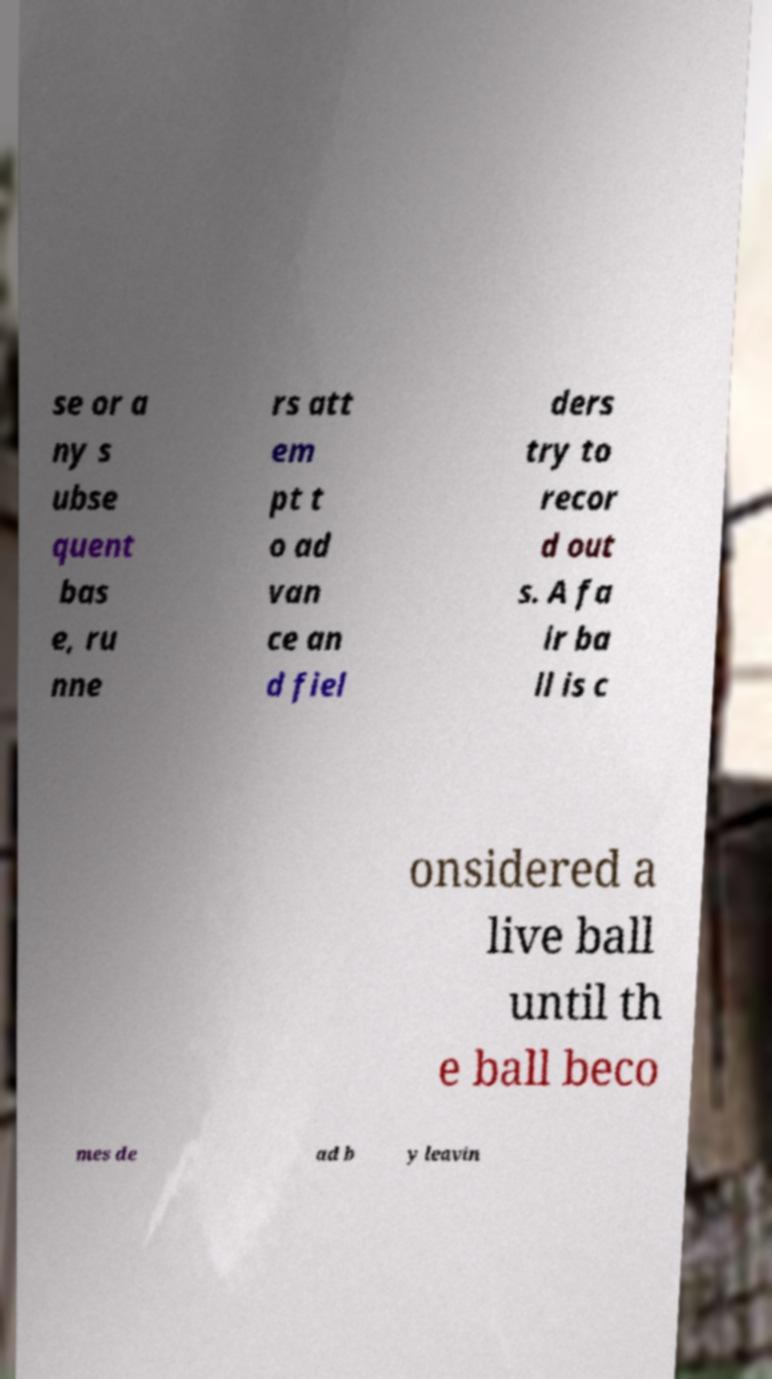For documentation purposes, I need the text within this image transcribed. Could you provide that? se or a ny s ubse quent bas e, ru nne rs att em pt t o ad van ce an d fiel ders try to recor d out s. A fa ir ba ll is c onsidered a live ball until th e ball beco mes de ad b y leavin 